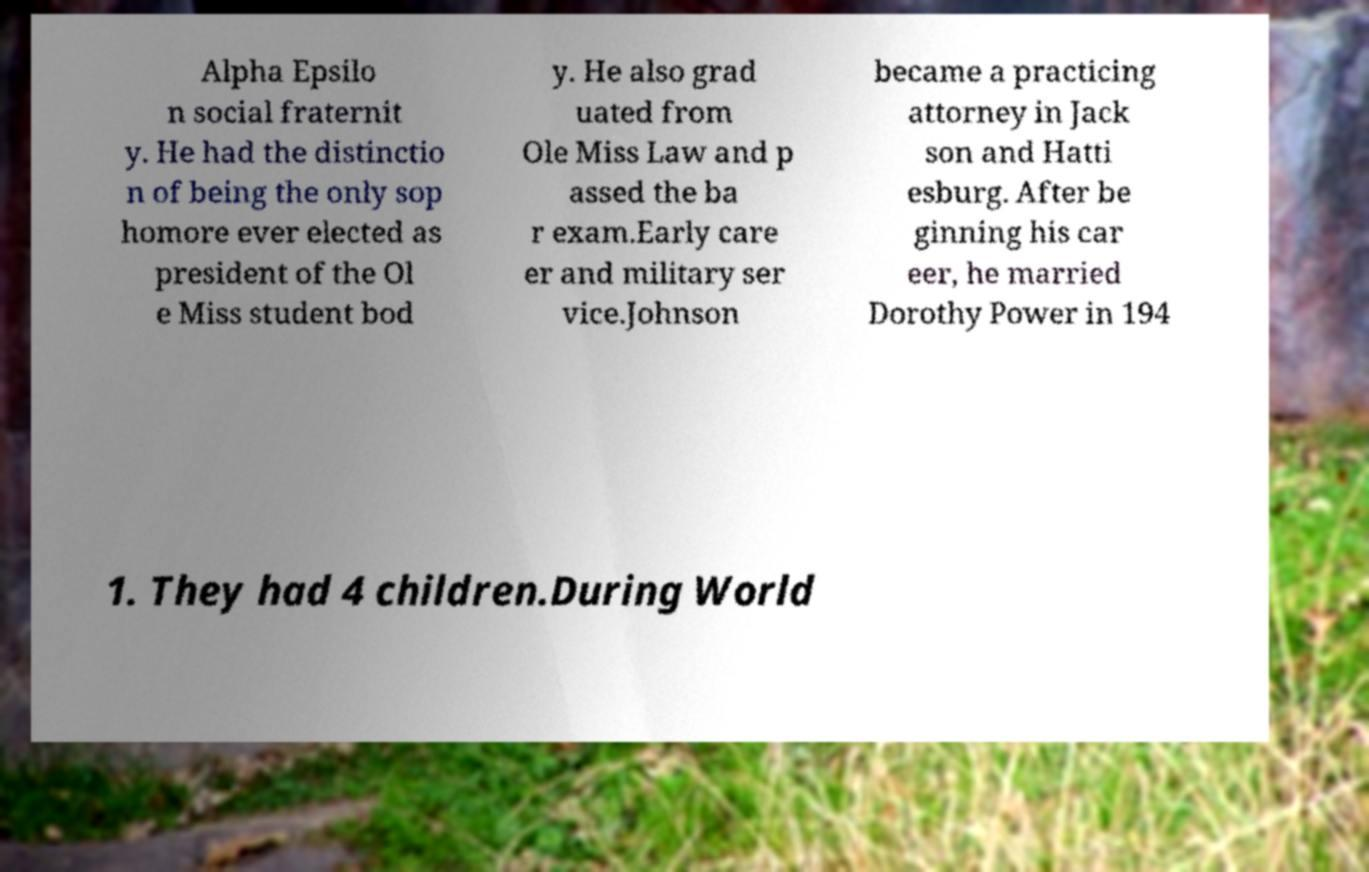For documentation purposes, I need the text within this image transcribed. Could you provide that? Alpha Epsilo n social fraternit y. He had the distinctio n of being the only sop homore ever elected as president of the Ol e Miss student bod y. He also grad uated from Ole Miss Law and p assed the ba r exam.Early care er and military ser vice.Johnson became a practicing attorney in Jack son and Hatti esburg. After be ginning his car eer, he married Dorothy Power in 194 1. They had 4 children.During World 